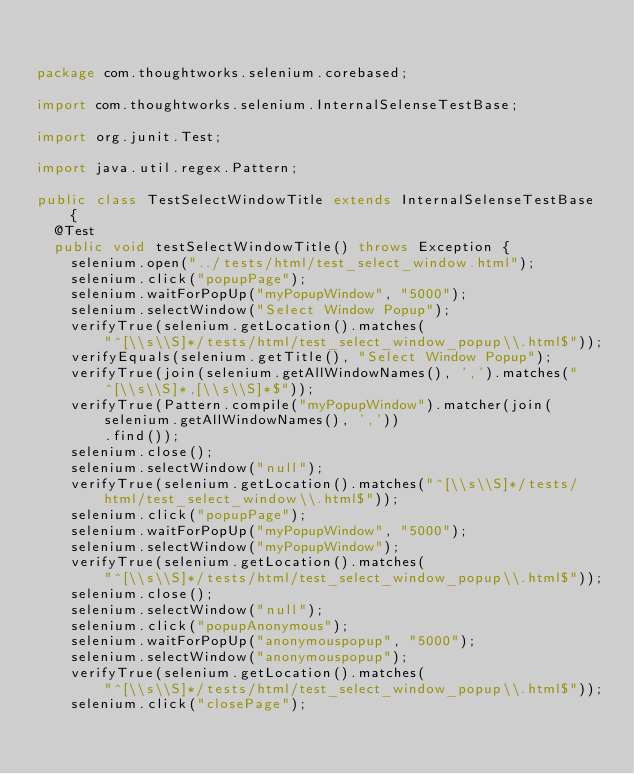<code> <loc_0><loc_0><loc_500><loc_500><_Java_>

package com.thoughtworks.selenium.corebased;

import com.thoughtworks.selenium.InternalSelenseTestBase;

import org.junit.Test;

import java.util.regex.Pattern;

public class TestSelectWindowTitle extends InternalSelenseTestBase {
  @Test
  public void testSelectWindowTitle() throws Exception {
    selenium.open("../tests/html/test_select_window.html");
    selenium.click("popupPage");
    selenium.waitForPopUp("myPopupWindow", "5000");
    selenium.selectWindow("Select Window Popup");
    verifyTrue(selenium.getLocation().matches(
        "^[\\s\\S]*/tests/html/test_select_window_popup\\.html$"));
    verifyEquals(selenium.getTitle(), "Select Window Popup");
    verifyTrue(join(selenium.getAllWindowNames(), ',').matches("^[\\s\\S]*,[\\s\\S]*$"));
    verifyTrue(Pattern.compile("myPopupWindow").matcher(join(selenium.getAllWindowNames(), ','))
        .find());
    selenium.close();
    selenium.selectWindow("null");
    verifyTrue(selenium.getLocation().matches("^[\\s\\S]*/tests/html/test_select_window\\.html$"));
    selenium.click("popupPage");
    selenium.waitForPopUp("myPopupWindow", "5000");
    selenium.selectWindow("myPopupWindow");
    verifyTrue(selenium.getLocation().matches(
        "^[\\s\\S]*/tests/html/test_select_window_popup\\.html$"));
    selenium.close();
    selenium.selectWindow("null");
    selenium.click("popupAnonymous");
    selenium.waitForPopUp("anonymouspopup", "5000");
    selenium.selectWindow("anonymouspopup");
    verifyTrue(selenium.getLocation().matches(
        "^[\\s\\S]*/tests/html/test_select_window_popup\\.html$"));
    selenium.click("closePage");</code> 